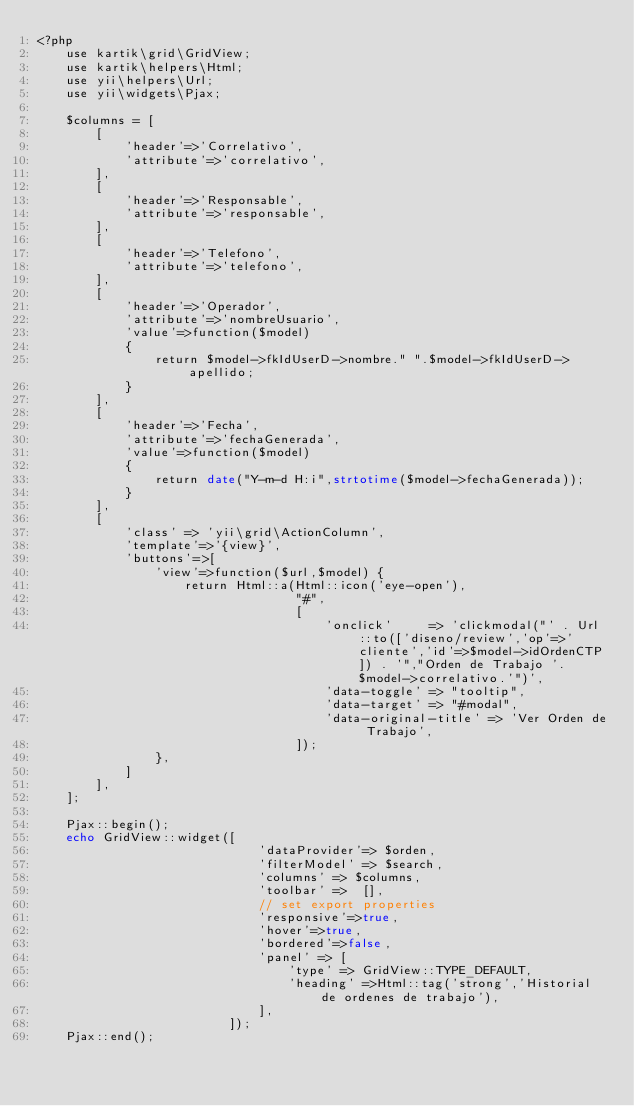<code> <loc_0><loc_0><loc_500><loc_500><_PHP_><?php
    use kartik\grid\GridView;
    use kartik\helpers\Html;
    use yii\helpers\Url;
    use yii\widgets\Pjax;

    $columns = [
        [
            'header'=>'Correlativo',
            'attribute'=>'correlativo',
        ],
        [
            'header'=>'Responsable',
            'attribute'=>'responsable',
        ],
        [
            'header'=>'Telefono',
            'attribute'=>'telefono',
        ],
        [
            'header'=>'Operador',
            'attribute'=>'nombreUsuario',
            'value'=>function($model)
            {
                return $model->fkIdUserD->nombre." ".$model->fkIdUserD->apellido;
            }
        ],
        [
            'header'=>'Fecha',
            'attribute'=>'fechaGenerada',
            'value'=>function($model)
            {
                return date("Y-m-d H:i",strtotime($model->fechaGenerada));
            }
        ],
        [
            'class' => 'yii\grid\ActionColumn',
            'template'=>'{view}',
            'buttons'=>[
                'view'=>function($url,$model) {
                    return Html::a(Html::icon('eye-open'),
                                   "#",
                                   [
                                       'onclick'     => 'clickmodal("' . Url::to(['diseno/review','op'=>'cliente','id'=>$model->idOrdenCTP]) . '","Orden de Trabajo '.$model->correlativo.'")',
                                       'data-toggle' => "tooltip",
                                       'data-target' => "#modal",
                                       'data-original-title' => 'Ver Orden de Trabajo',
                                   ]);
                },
            ]
        ],
    ];

    Pjax::begin();
    echo GridView::widget([
                              'dataProvider'=> $orden,
                              'filterModel' => $search,
                              'columns' => $columns,
                              'toolbar' =>  [],
                              // set export properties
                              'responsive'=>true,
                              'hover'=>true,
                              'bordered'=>false,
                              'panel' => [
                                  'type' => GridView::TYPE_DEFAULT,
                                  'heading' =>Html::tag('strong','Historial de ordenes de trabajo'),
                              ],
                          ]);
    Pjax::end();
</code> 